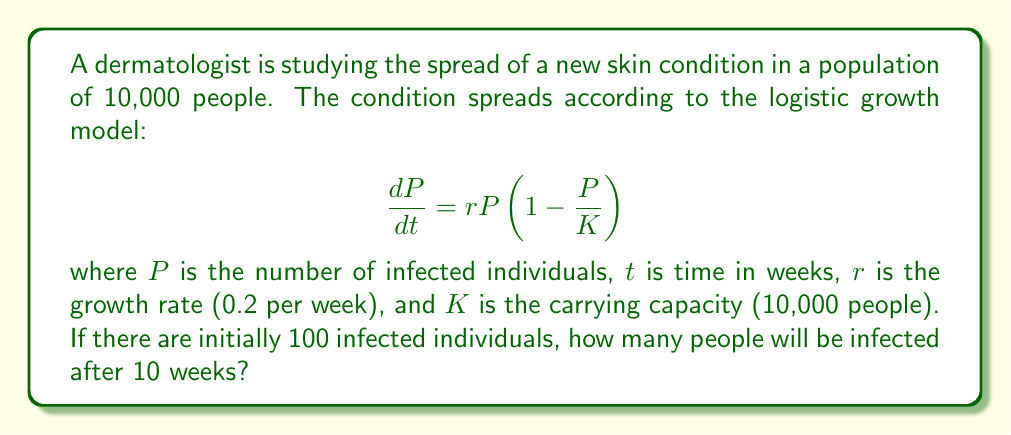Can you solve this math problem? To solve this problem, we need to use the logistic growth model and its solution:

1. The logistic growth equation is given by:
   $$\frac{dP}{dt} = rP(1-\frac{P}{K})$$

2. The solution to this differential equation is:
   $$P(t) = \frac{K}{1 + (\frac{K}{P_0} - 1)e^{-rt}}$$

   where $P_0$ is the initial number of infected individuals.

3. We are given the following parameters:
   - $K = 10,000$ (carrying capacity)
   - $r = 0.2$ (growth rate per week)
   - $P_0 = 100$ (initial infected population)
   - $t = 10$ (time in weeks)

4. Let's substitute these values into the solution:
   $$P(10) = \frac{10,000}{1 + (\frac{10,000}{100} - 1)e^{-0.2 \times 10}}$$

5. Simplify:
   $$P(10) = \frac{10,000}{1 + 99e^{-2}}$$

6. Calculate $e^{-2} \approx 0.1353$:
   $$P(10) = \frac{10,000}{1 + 99 \times 0.1353} \approx \frac{10,000}{14.3947}$$

7. Solve:
   $$P(10) \approx 694.7$$

8. Since we're dealing with people, we round to the nearest whole number:
   $$P(10) \approx 695$$

Therefore, after 10 weeks, approximately 695 people will be infected with the skin condition.
Answer: 695 people 